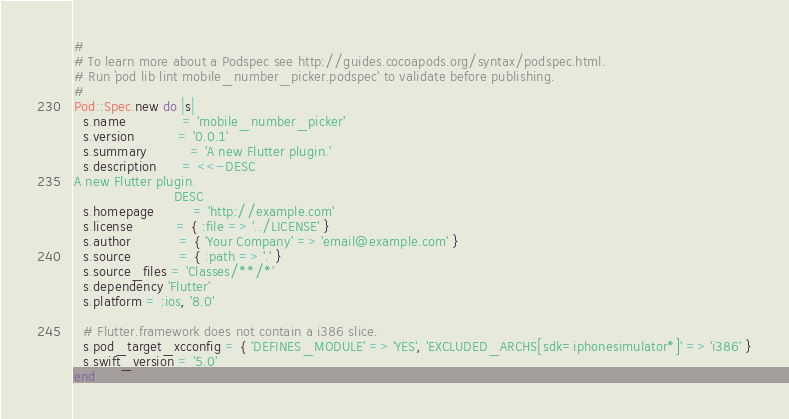Convert code to text. <code><loc_0><loc_0><loc_500><loc_500><_Ruby_>#
# To learn more about a Podspec see http://guides.cocoapods.org/syntax/podspec.html.
# Run `pod lib lint mobile_number_picker.podspec' to validate before publishing.
#
Pod::Spec.new do |s|
  s.name             = 'mobile_number_picker'
  s.version          = '0.0.1'
  s.summary          = 'A new Flutter plugin.'
  s.description      = <<-DESC
A new Flutter plugin.
                       DESC
  s.homepage         = 'http://example.com'
  s.license          = { :file => '../LICENSE' }
  s.author           = { 'Your Company' => 'email@example.com' }
  s.source           = { :path => '.' }
  s.source_files = 'Classes/**/*'
  s.dependency 'Flutter'
  s.platform = :ios, '8.0'

  # Flutter.framework does not contain a i386 slice.
  s.pod_target_xcconfig = { 'DEFINES_MODULE' => 'YES', 'EXCLUDED_ARCHS[sdk=iphonesimulator*]' => 'i386' }
  s.swift_version = '5.0'
end
</code> 